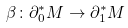<formula> <loc_0><loc_0><loc_500><loc_500>\beta \colon \partial ^ { * } _ { 0 } M \to \partial ^ { * } _ { 1 } M</formula> 